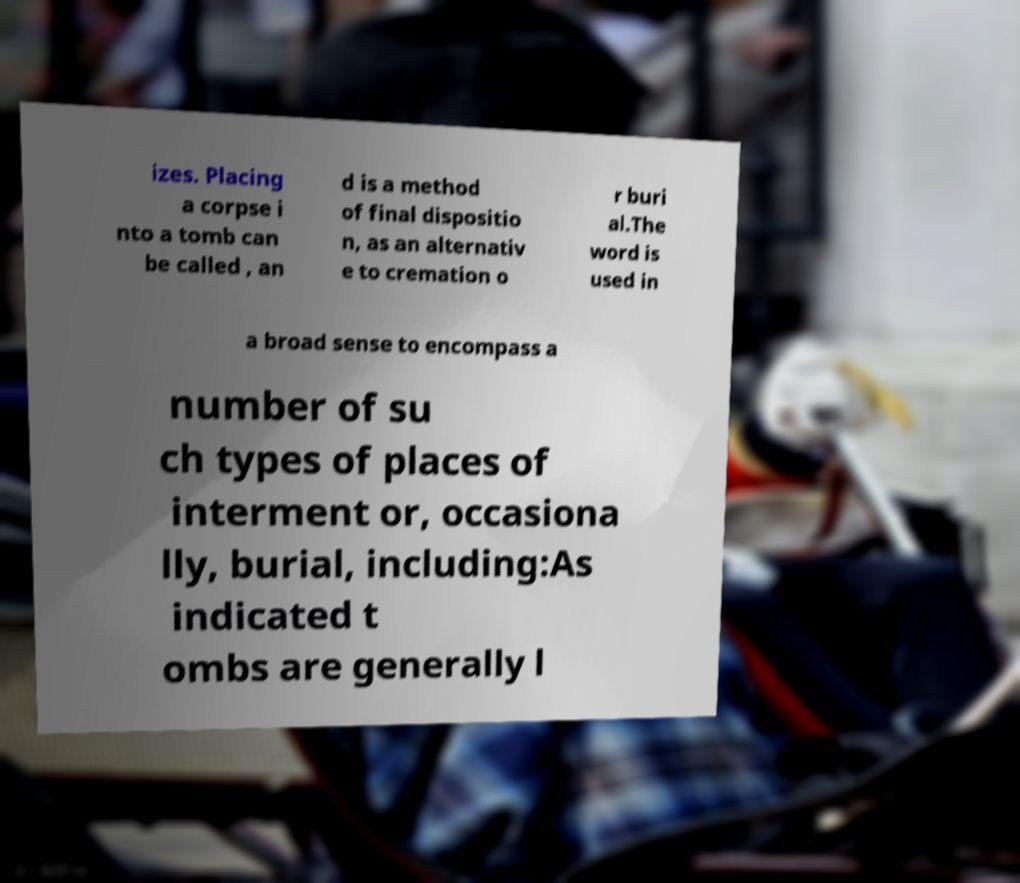For documentation purposes, I need the text within this image transcribed. Could you provide that? izes. Placing a corpse i nto a tomb can be called , an d is a method of final dispositio n, as an alternativ e to cremation o r buri al.The word is used in a broad sense to encompass a number of su ch types of places of interment or, occasiona lly, burial, including:As indicated t ombs are generally l 